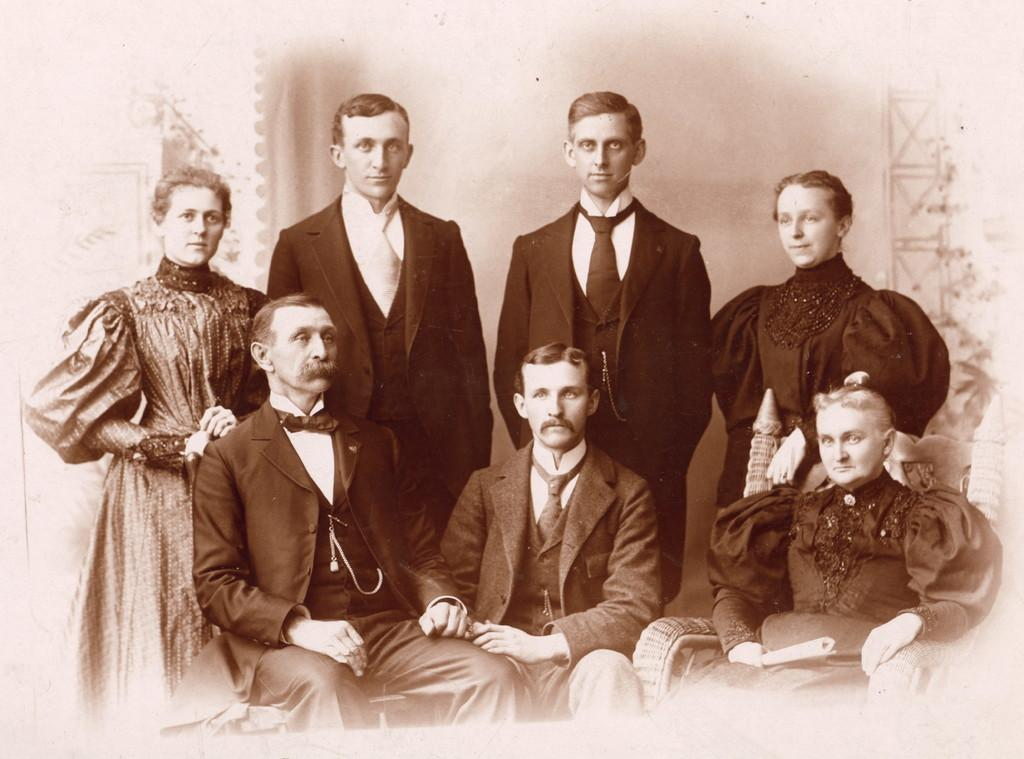What is the main subject of the image? The main subject of the image is a photograph. What can be seen in the photograph? There is a group of persons in the photograph. Can you describe the positions of the persons in the photograph? Some of the persons are sitting, while others are standing. What is visible in the background of the photograph? There is a curtain and a wall in the background of the photograph. Where is the faucet located in the image? There is no faucet present in the image. What type of clam is visible in the photograph? There are no clams present in the image; it features a photograph of a group of persons. 